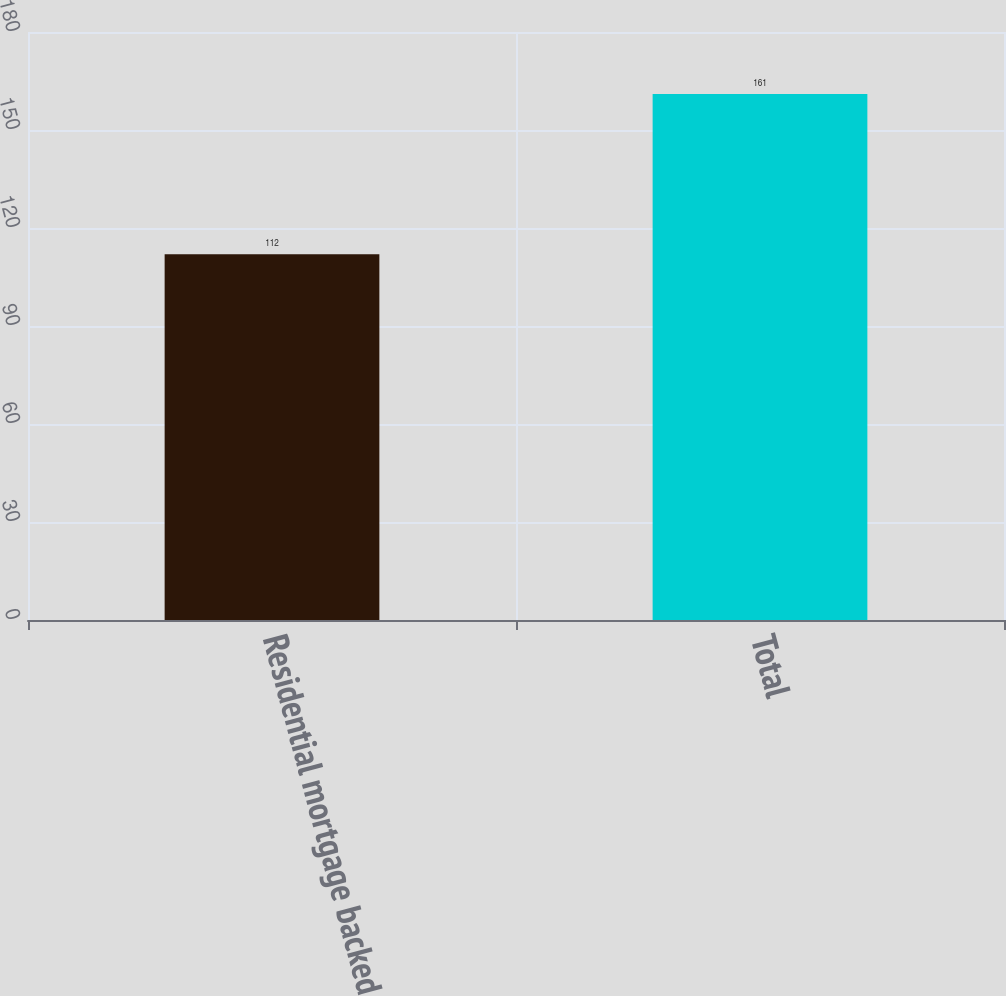<chart> <loc_0><loc_0><loc_500><loc_500><bar_chart><fcel>Residential mortgage backed<fcel>Total<nl><fcel>112<fcel>161<nl></chart> 